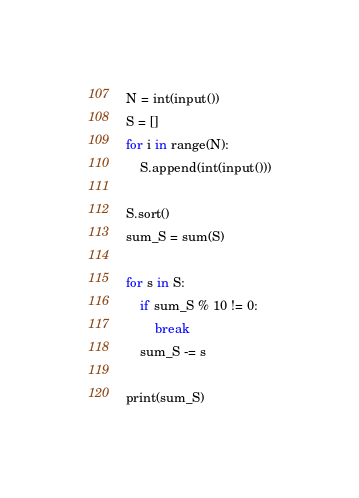Convert code to text. <code><loc_0><loc_0><loc_500><loc_500><_Python_>N = int(input())
S = []
for i in range(N):
    S.append(int(input()))

S.sort()
sum_S = sum(S)

for s in S:
    if sum_S % 10 != 0:
        break
    sum_S -= s

print(sum_S)
</code> 